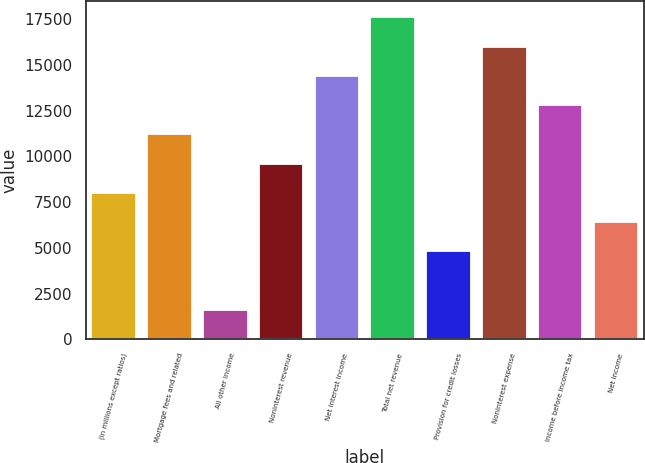Convert chart. <chart><loc_0><loc_0><loc_500><loc_500><bar_chart><fcel>(in millions except ratios)<fcel>Mortgage fees and related<fcel>All other income<fcel>Noninterest revenue<fcel>Net interest income<fcel>Total net revenue<fcel>Provision for credit losses<fcel>Noninterest expense<fcel>Income before income tax<fcel>Net income<nl><fcel>8005<fcel>11203<fcel>1609<fcel>9604<fcel>14401<fcel>17599<fcel>4807<fcel>16000<fcel>12802<fcel>6406<nl></chart> 